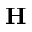Convert formula to latex. <formula><loc_0><loc_0><loc_500><loc_500>H</formula> 